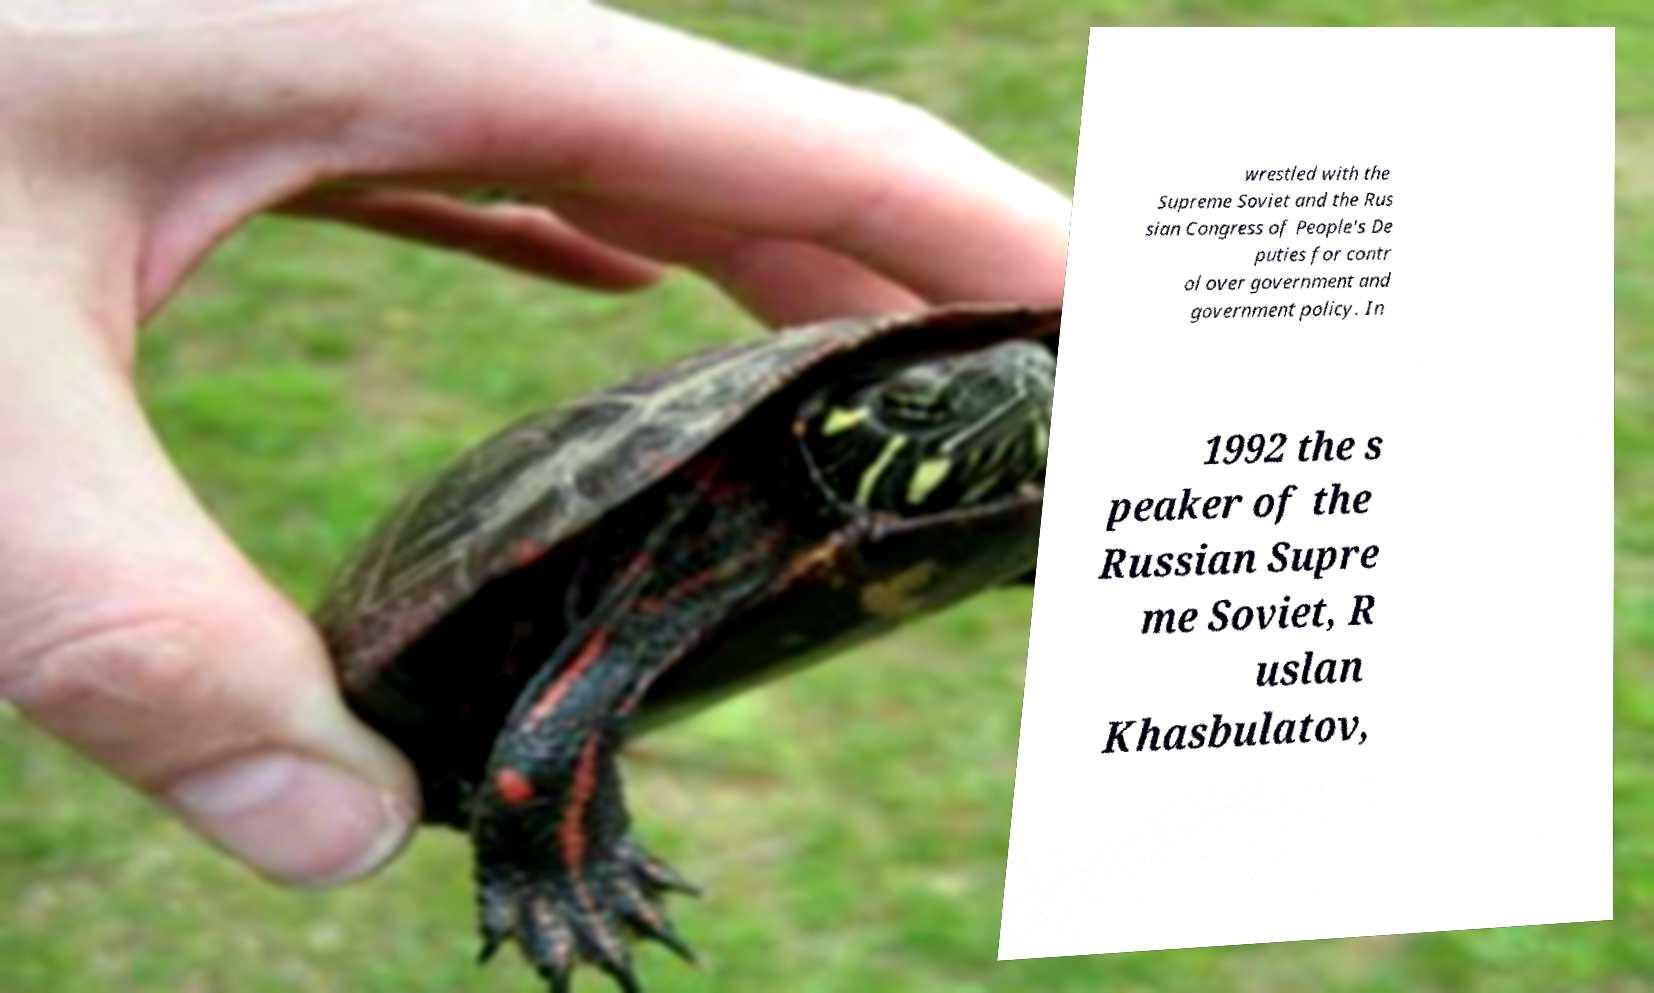Could you extract and type out the text from this image? wrestled with the Supreme Soviet and the Rus sian Congress of People's De puties for contr ol over government and government policy. In 1992 the s peaker of the Russian Supre me Soviet, R uslan Khasbulatov, 